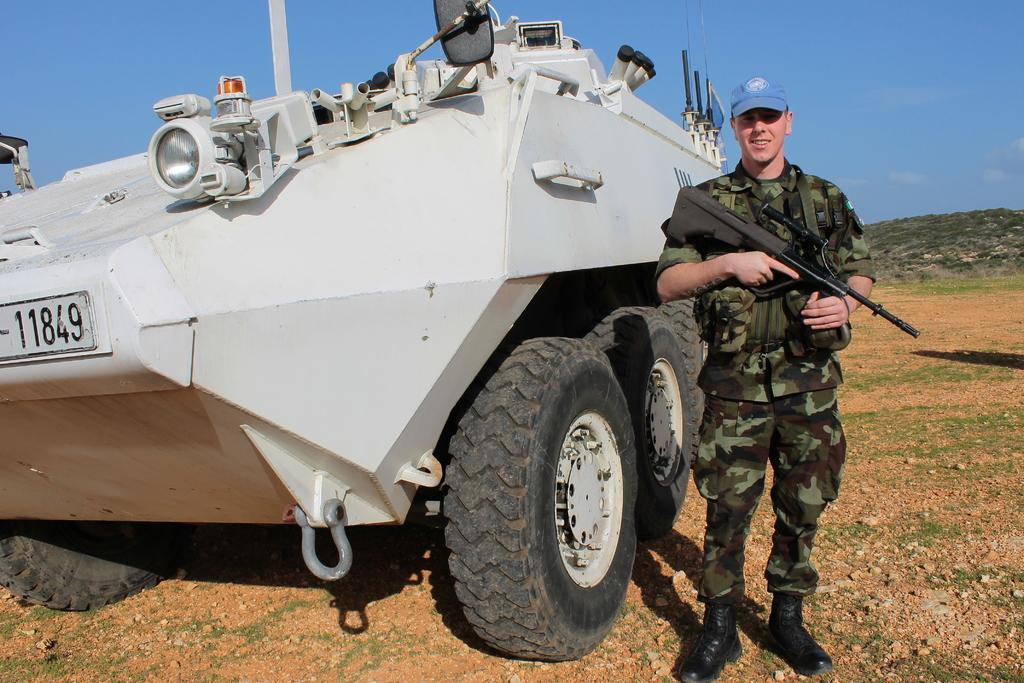What is the main subject of the image? The main subject of the image is a man. What is the man wearing in the image? The man is wearing an army dress in the image. What is the man holding in the image? The man is holding a gun in the image. What can be seen on the left side of the man? There is an armored vehicle on the left side of the man. What type of natural feature is visible behind the man? There is a hill visible behind the man. What part of the environment is visible in the image? The sky is visible in the image. What type of tramp can be seen in the image? There is no tramp present in the image. What title does the man hold in the image? The facts provided do not mention any specific title or rank for the man. 